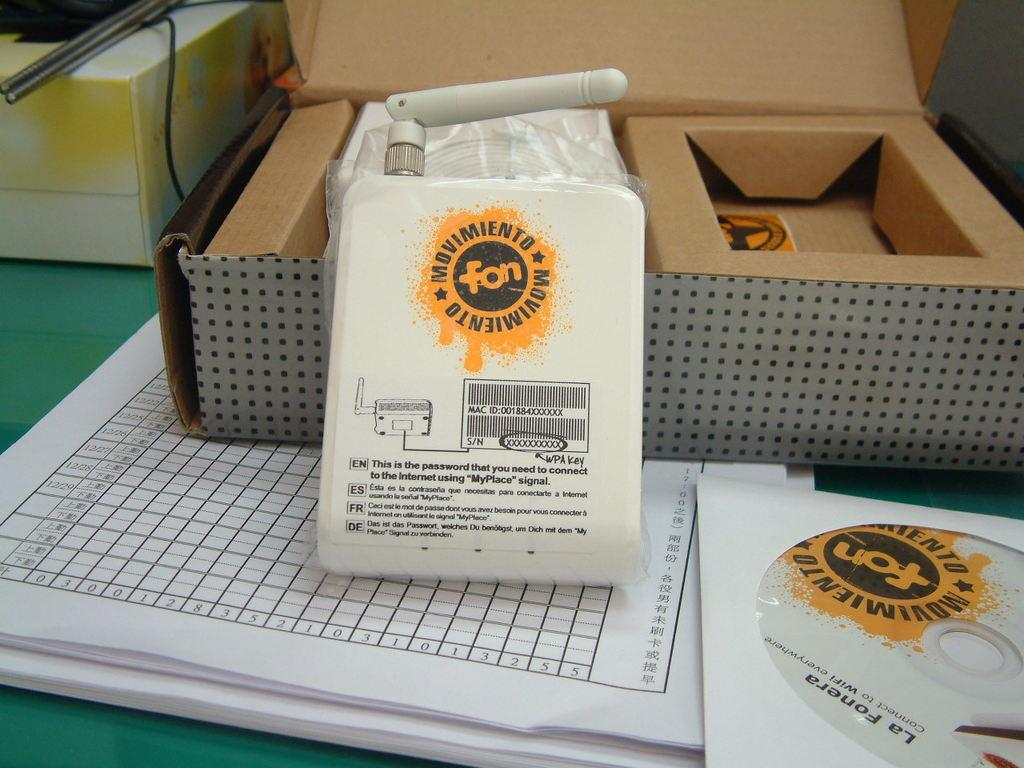<image>
Present a compact description of the photo's key features. An open box with a white package in front of it that says Movimiento with a yellow label. 